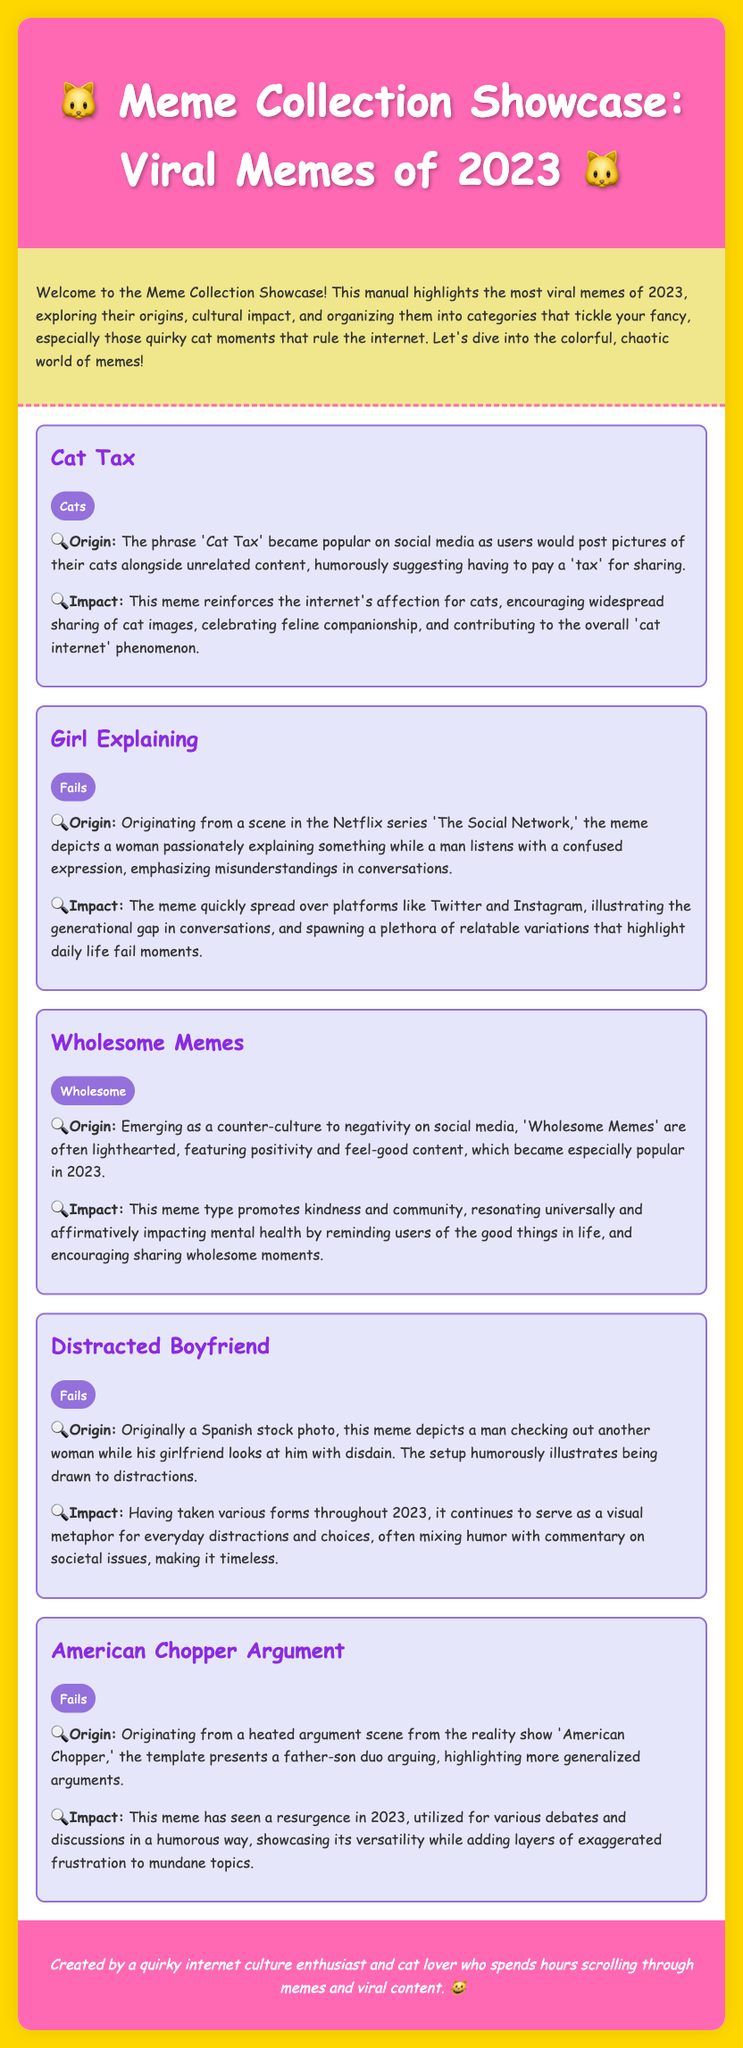What is the title of the manual? The title of the manual is presented prominently at the top of the document, stating the focus on viral memes of 2023.
Answer: Meme Collection Showcase: Viral Memes of 2023 How many main categories are highlighted in the document? The document features multiple sections, with each meme categorized into distinct themes that are listed in the content.
Answer: Three What is the origin of the "Cat Tax" meme? The document details that the "Cat Tax" originated from social media users posting pictures of their cats alongside unrelated content.
Answer: Posting pictures of their cats alongside unrelated content Which meme is categorized under "Wholesome"? The categorization of memes is specified under each meme title, explicitly marking which ones fit into which theme.
Answer: Wholesome Memes What does the "Distracted Boyfriend" meme illustrate? The document explains that this meme serves as a visual metaphor for everyday distractions and choices.
Answer: Everyday distractions and choices What underlying theme does the "Wholesome Memes" section promote? The commentary in the document indicates a focus on positivity and community in this meme category, aiming for a certain emotional impact.
Answer: Kindness and community What kind of content does the manual explore? The purpose of the manual is outlined in the introduction, indicating the types of content it covers regarding memes.
Answer: Viral memes of 2023 What visuals accompany the meme discussions in the manual? The structure of the document implies that each meme has its own visual representation although they are not included in the text itself.
Answer: Not included in the text How does the document reflect the personality of its creator? The closing footer reveals details about the creator, hinting at their interests and personality traits related to internet culture.
Answer: Quirky internet culture enthusiast and cat lover 